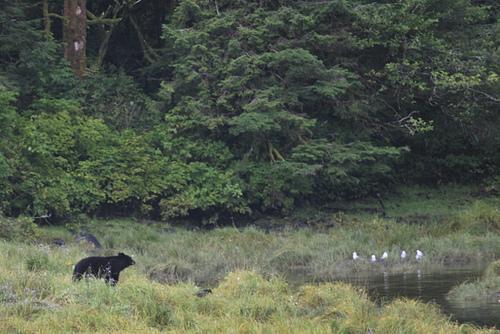How many birds are pictured?
Give a very brief answer. 5. 